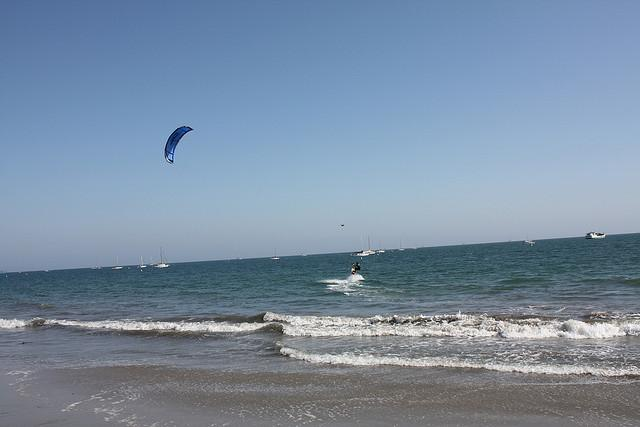The shape of the paragliding inflatable wing is? Please explain your reasoning. elliptical. This is the only shape that will use the wind correctly to pick up the person. 